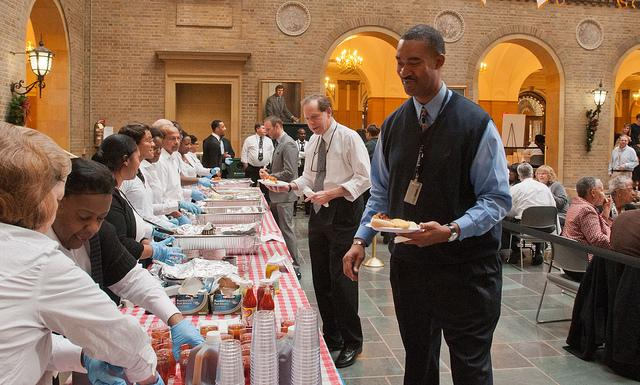Why should they wear gloves? germs 